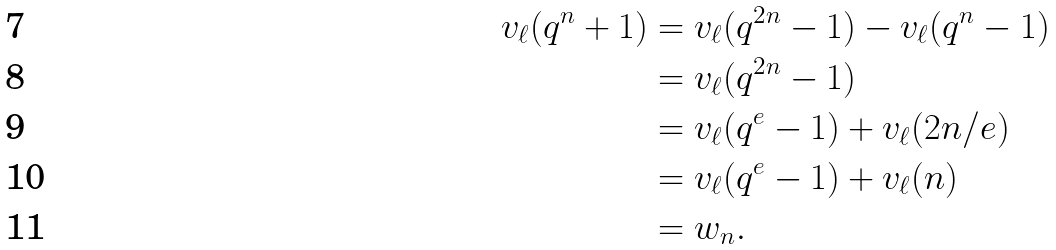<formula> <loc_0><loc_0><loc_500><loc_500>v _ { \ell } ( q ^ { n } + 1 ) & = v _ { \ell } ( q ^ { 2 n } - 1 ) - v _ { \ell } ( q ^ { n } - 1 ) \\ & = v _ { \ell } ( q ^ { 2 n } - 1 ) \\ & = v _ { \ell } ( q ^ { e } - 1 ) + v _ { \ell } ( 2 n / e ) \\ & = v _ { \ell } ( q ^ { e } - 1 ) + v _ { \ell } ( n ) \\ & = w _ { n } .</formula> 